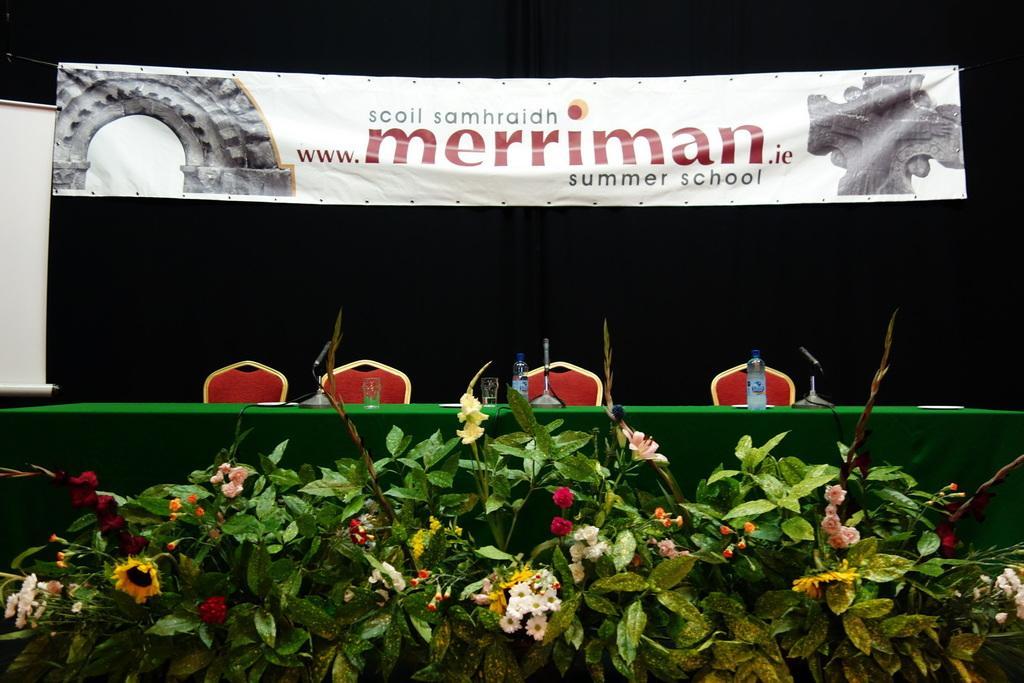How would you summarize this image in a sentence or two? There are flower plants in the foreground area of the image, there are bottles, glasses and mics on the table, chairs, a poster and curtain in the background. 